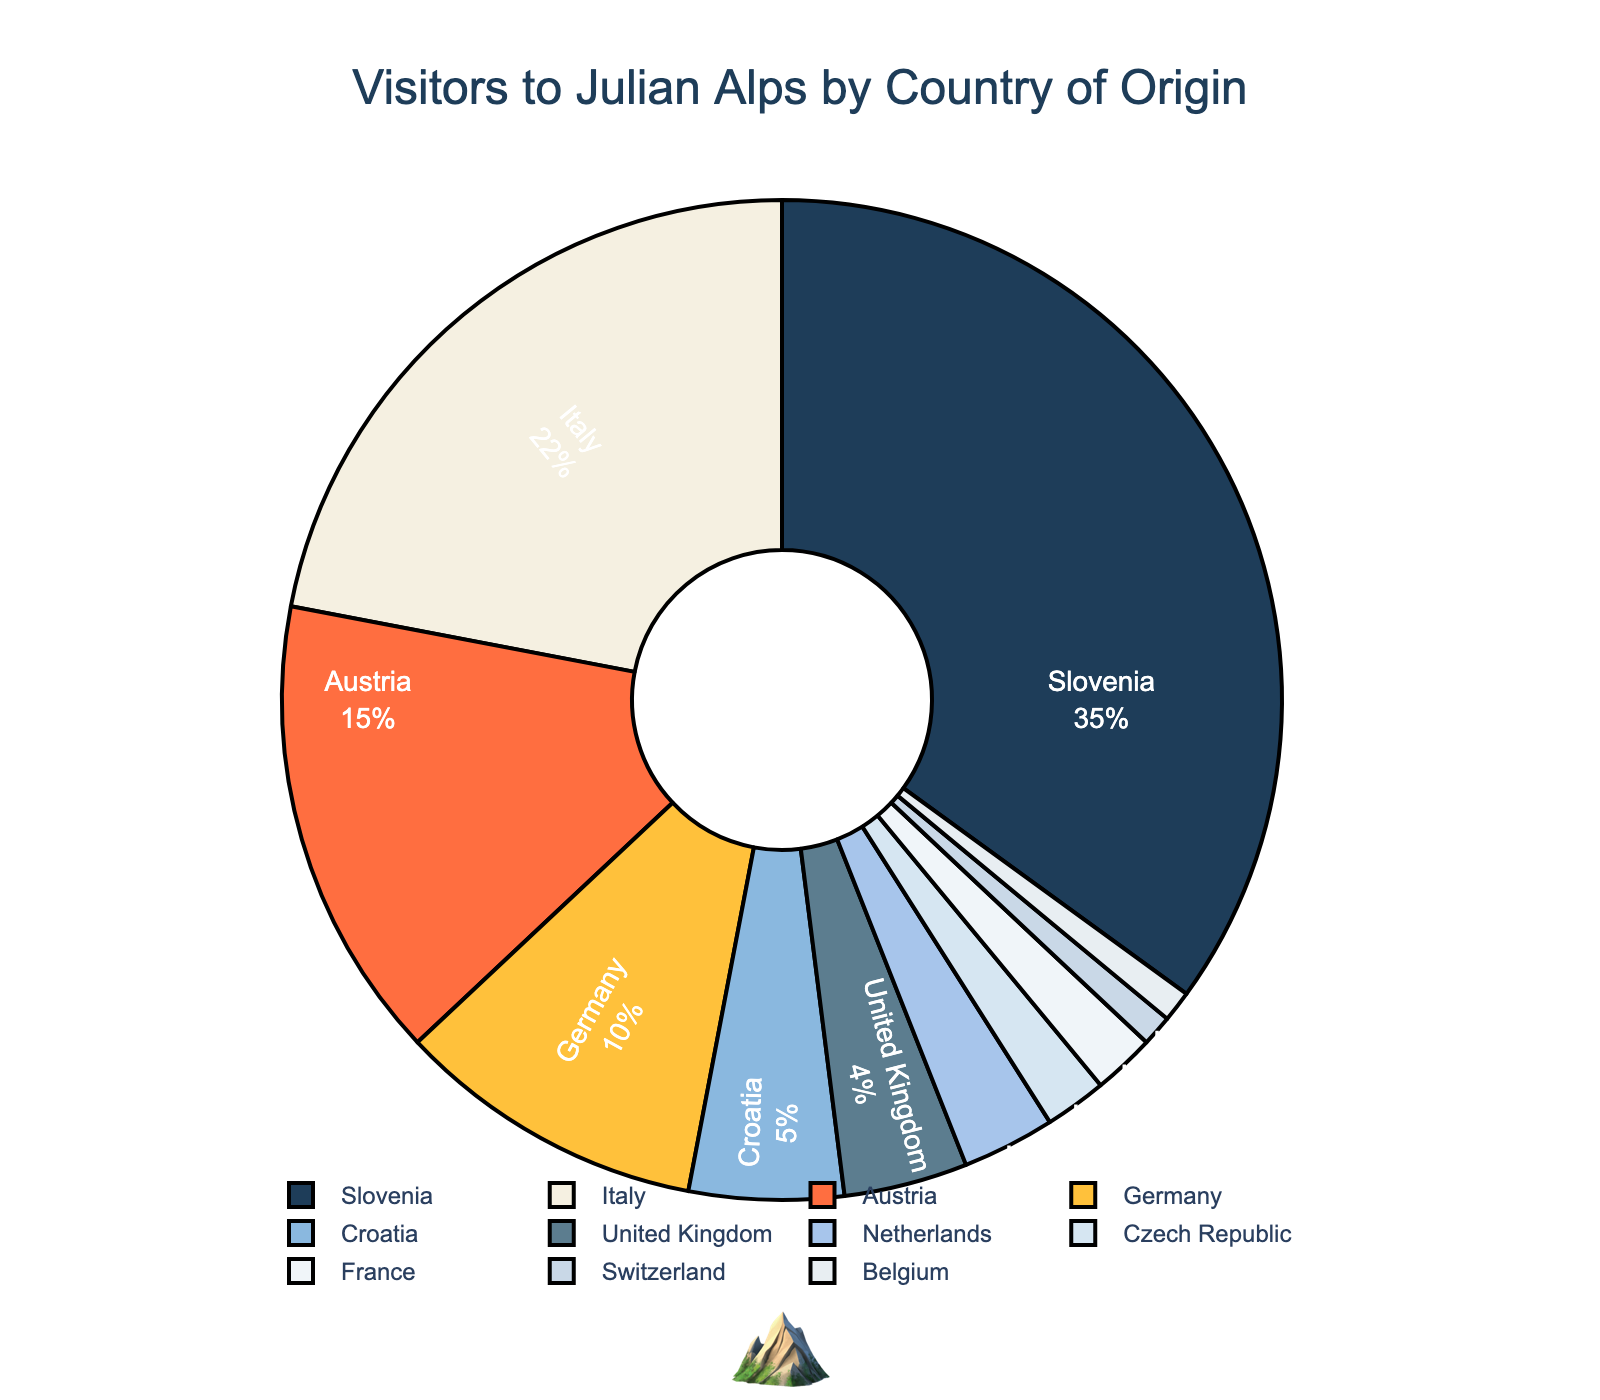Which country has the highest percentage of visitors? The figure shows a pie chart labeled by country and percentage of origin of visitors. The largest segment of the chart represents Slovenia with 35%.
Answer: Slovenia What's the combined percentage of visitors from Germany and Austria? Locate the segments corresponding to Germany (10%) and Austria (15%) in the pie chart. Add these values together: 10 + 15.
Answer: 25% Which country has a higher percentage of visitors, Italy or Croatia, and by how much? Identify the percentages for Italy (22%) and Croatia (5%) in the chart. Subtract the smaller percentage from the larger one to find the difference: 22 - 5.
Answer: Italy, by 17% What proportion of visitors come from countries other than Slovenia, Italy, and Austria? First, find the total percentage for Slovenia (35%), Italy (22%), and Austria (15%). Then subtract this combined total from 100%: 100 - (35 + 22 + 15).
Answer: 28% What is the visual attribute of the segment representing Switzerland? The segment representing Switzerland is colored to match the chart's color scheme and features a thin black outline, but the specific color is a pale blue shade with a white font.
Answer: Pale blue shade with white font Which country shares the smallest segment size with the smallest percentage? Look at the pie chart and identify the smallest segment. The smallest percentage provided for a country is 1%, represented by Switzerland and Belgium.
Answer: Switzerland or Belgium How many countries contribute less than 5% of visitors each? Identify each country with a percentage less than 5%: United Kingdom (4%), Netherlands (3%), Czech Republic (2%), France (2%), Switzerland (1%), and Belgium (1%). Count these countries: 1, 2, 3, 4, 5, 6.
Answer: 6 countries Compare the percentage difference between the highest and lowest contributors. The highest contributor, Slovenia, has 35% and the lowest contributors, Switzerland and Belgium, each have 1%. Subtract the lowest from the highest: 35 - 1.
Answer: 34% What percentage of visitors come from countries with more than a 10% share? Identify the countries with percentages greater than 10% (Slovenia: 35%, Italy: 22%, and Austria: 15%). Sum these percentages: 35 + 22 + 15.
Answer: 72% Which countries' segments are next to each other visually in the pie chart? By examining the layout of the pie chart's segments, we see the countries positioned adjacently include (for example) Slovenia next to Italy, and Czech Republic next to France. Specific adjacency depends on chart rotation.
Answer: Variable depending on layout details 